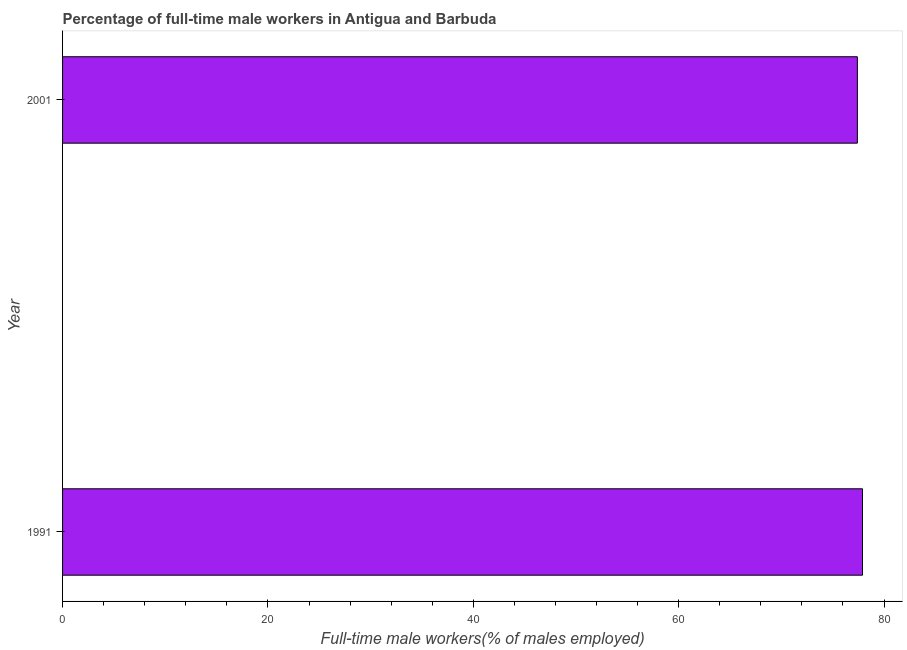Does the graph contain grids?
Give a very brief answer. No. What is the title of the graph?
Provide a succinct answer. Percentage of full-time male workers in Antigua and Barbuda. What is the label or title of the X-axis?
Your answer should be compact. Full-time male workers(% of males employed). What is the label or title of the Y-axis?
Your response must be concise. Year. What is the percentage of full-time male workers in 1991?
Your answer should be very brief. 77.9. Across all years, what is the maximum percentage of full-time male workers?
Ensure brevity in your answer.  77.9. Across all years, what is the minimum percentage of full-time male workers?
Your answer should be compact. 77.4. What is the sum of the percentage of full-time male workers?
Offer a terse response. 155.3. What is the difference between the percentage of full-time male workers in 1991 and 2001?
Make the answer very short. 0.5. What is the average percentage of full-time male workers per year?
Offer a terse response. 77.65. What is the median percentage of full-time male workers?
Provide a succinct answer. 77.65. In how many years, is the percentage of full-time male workers greater than 24 %?
Your response must be concise. 2. How many bars are there?
Your answer should be compact. 2. How many years are there in the graph?
Give a very brief answer. 2. Are the values on the major ticks of X-axis written in scientific E-notation?
Provide a short and direct response. No. What is the Full-time male workers(% of males employed) in 1991?
Ensure brevity in your answer.  77.9. What is the Full-time male workers(% of males employed) of 2001?
Your answer should be very brief. 77.4. What is the difference between the Full-time male workers(% of males employed) in 1991 and 2001?
Make the answer very short. 0.5. 